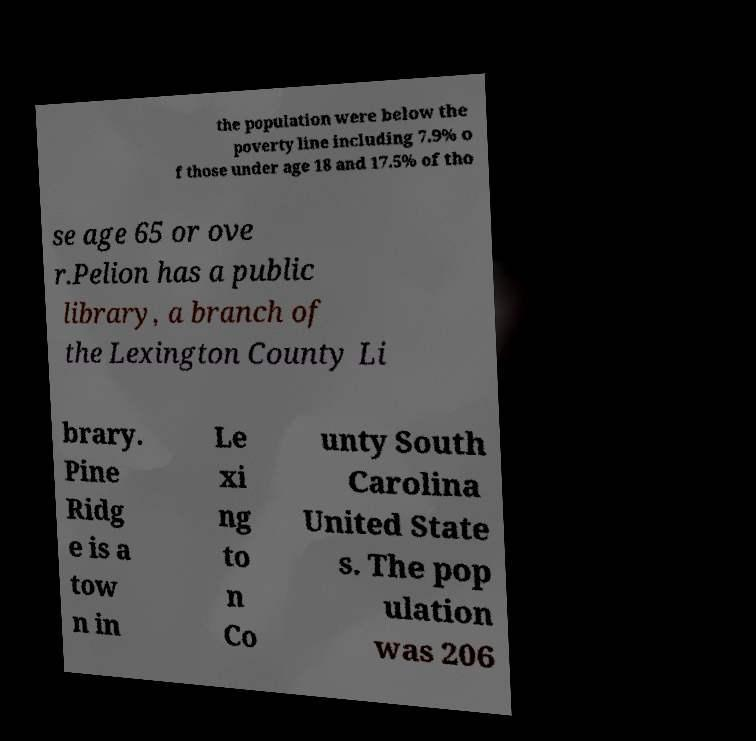What messages or text are displayed in this image? I need them in a readable, typed format. the population were below the poverty line including 7.9% o f those under age 18 and 17.5% of tho se age 65 or ove r.Pelion has a public library, a branch of the Lexington County Li brary. Pine Ridg e is a tow n in Le xi ng to n Co unty South Carolina United State s. The pop ulation was 206 